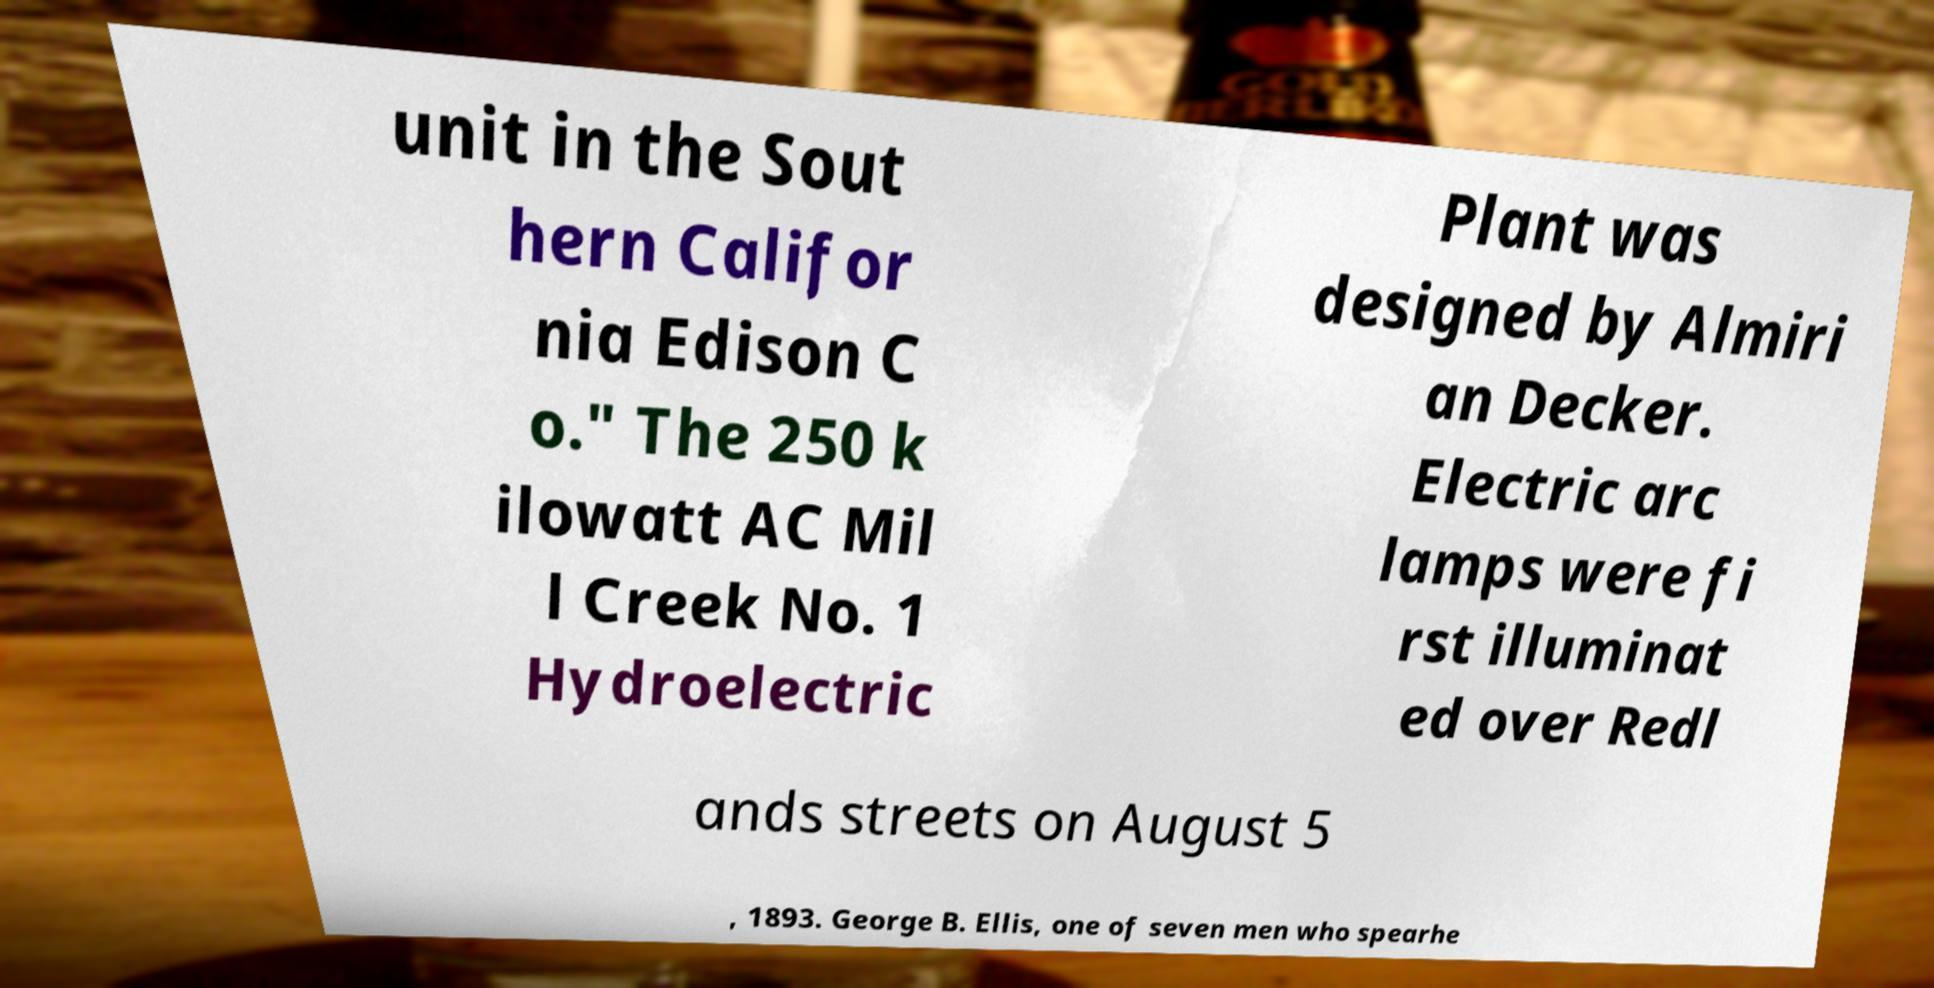For documentation purposes, I need the text within this image transcribed. Could you provide that? unit in the Sout hern Califor nia Edison C o." The 250 k ilowatt AC Mil l Creek No. 1 Hydroelectric Plant was designed by Almiri an Decker. Electric arc lamps were fi rst illuminat ed over Redl ands streets on August 5 , 1893. George B. Ellis, one of seven men who spearhe 